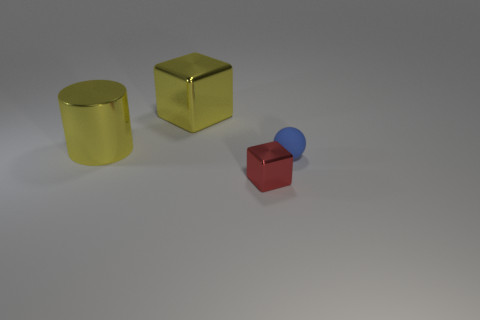Is the material of the small thing behind the tiny red thing the same as the object that is behind the large yellow metal cylinder?
Give a very brief answer. No. Do the yellow block and the sphere to the right of the large cylinder have the same material?
Your answer should be very brief. No. What size is the shiny block in front of the big yellow metal cylinder behind the small object behind the red shiny object?
Your response must be concise. Small. What number of cylinders are the same color as the big metallic cube?
Your answer should be compact. 1. How many other big yellow cylinders have the same material as the yellow cylinder?
Ensure brevity in your answer.  0. What number of things are small blocks or shiny things that are in front of the blue rubber thing?
Keep it short and to the point. 1. The metal object that is in front of the big object to the left of the cube left of the tiny metallic cube is what color?
Your answer should be very brief. Red. There is a block that is in front of the large yellow metal block; how big is it?
Ensure brevity in your answer.  Small. What number of tiny things are either green rubber objects or red shiny things?
Ensure brevity in your answer.  1. What is the color of the metallic thing that is on the right side of the big cylinder and in front of the yellow metallic block?
Give a very brief answer. Red. 